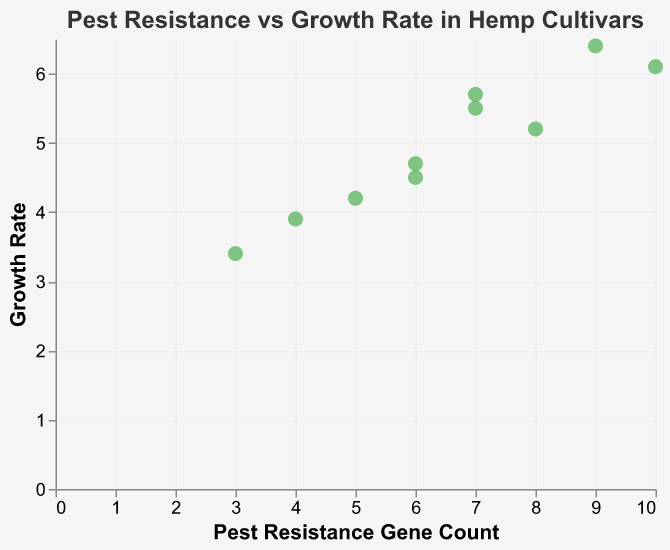How many cultivars are represented in the scatter plot? The scatter plot shows 10 distinct data points, and each point represents a unique cultivar of hemp. Therefore, the number of cultivars is equal to the number of data points.
Answer: 10 What is the title of the scatter plot? The title of the scatter plot is displayed at the top of the chart. It is "Pest Resistance vs Growth Rate in Hemp Cultivars."
Answer: Pest Resistance vs Growth Rate in Hemp Cultivars Which cultivar has the highest growth rate? To find the cultivar with the highest growth rate, look for the point with the maximum y-value. "Helena" has the highest growth rate at 6.4.
Answer: Helena How many genes for pest resistance does the cultivar Carmagnola have? Locate the point representing "Carmagnola" and refer to its tooltip information, which shows that it has a pest resistance gene count of 10.
Answer: 10 What's the difference in growth rate between the cultivars with the highest and lowest pest resistance gene counts? Helena has the highest pest resistance gene count (9) but the highest growth rate (6.4) belongs to Carmagnola (10 genes). Tiborszallasi has the lowest pest resistance gene count (3). Subtract the growth rate of Tiborszallasi (3.4) from the growth rate of Carmagnola (6.1), resulting in a difference of 2.7.
Answer: 2.7 Is there a noticeable trend between pest resistance gene count and growth rate? Observing the scatter plot as a whole, it seems that there is a slight positive correlation: cultivars with more pest resistance genes tend to have higher growth rates. However, this relationship is not perfectly consistent for all points.
Answer: Slight positive correlation Which cultivar has the greatest difference between pest resistance gene count and growth rate, and what is this difference? Find the difference by subtracting the growth rate from the pest resistance gene count for each cultivar. "Carmagnola" has a gene count of 10 and a growth rate of 6.1, resulting in a difference of 3.9 which is the largest.
Answer: Carmagnola, 3.9 What is the average growth rate of the cultivars with pest resistance gene counts greater than 6? Identify the cultivars with pest resistance gene counts greater than 6: Finola, Helena, Carmagnola, Fedora17, Santhica27. Their growth rates are 5.2, 6.4, 6.1, 5.5, and 5.7, respectively. The sum of these growth rates is 28.9 and the average is 28.9/5 = 5.78.
Answer: 5.78 Which two cultivars have the closest growth rates? Compare the growth rates of each pair of cultivars and find the smallest difference. "Kompolti" and "Fibranova" have growth rates of 4.7 and 4.5, respectively, with a difference of 0.2, which is the smallest.
Answer: Kompolti and Fibranova Does any cultivar have the same value for both pest resistance gene count and growth rate? Compare the pest resistance gene count and growth rate for each cultivar. None of the cultivars have matching values for both attributes.
Answer: No 